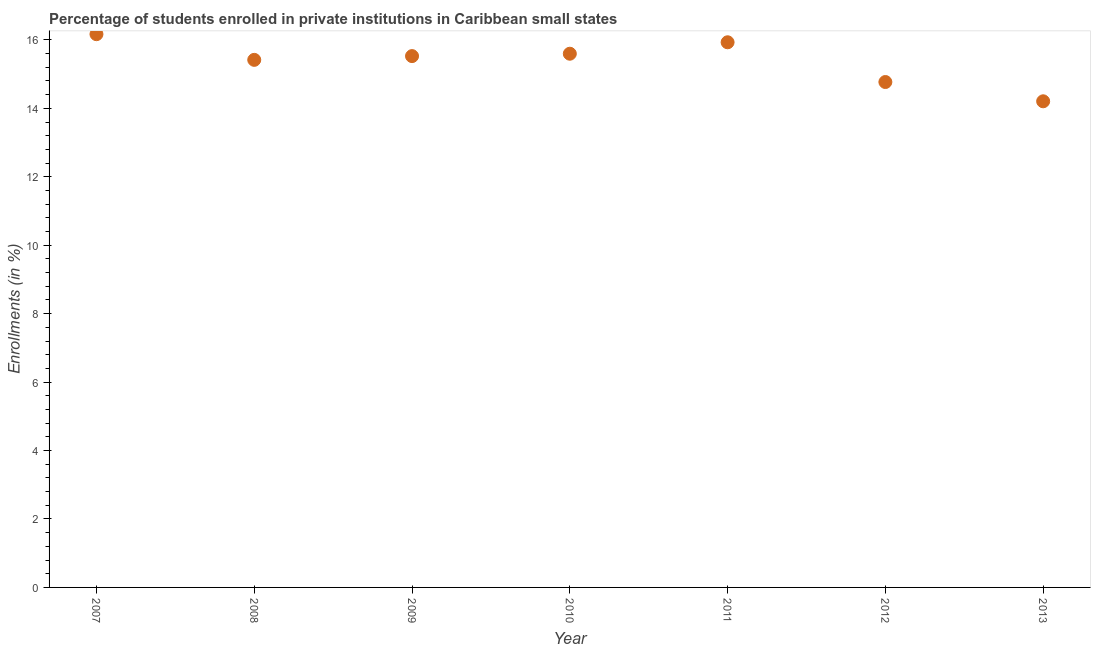What is the enrollments in private institutions in 2012?
Offer a terse response. 14.77. Across all years, what is the maximum enrollments in private institutions?
Your answer should be very brief. 16.17. Across all years, what is the minimum enrollments in private institutions?
Make the answer very short. 14.21. In which year was the enrollments in private institutions maximum?
Provide a succinct answer. 2007. What is the sum of the enrollments in private institutions?
Give a very brief answer. 107.62. What is the difference between the enrollments in private institutions in 2007 and 2008?
Provide a short and direct response. 0.75. What is the average enrollments in private institutions per year?
Your response must be concise. 15.37. What is the median enrollments in private institutions?
Offer a terse response. 15.53. Do a majority of the years between 2009 and 2010 (inclusive) have enrollments in private institutions greater than 8 %?
Offer a very short reply. Yes. What is the ratio of the enrollments in private institutions in 2008 to that in 2012?
Provide a short and direct response. 1.04. Is the enrollments in private institutions in 2008 less than that in 2010?
Keep it short and to the point. Yes. What is the difference between the highest and the second highest enrollments in private institutions?
Offer a very short reply. 0.24. What is the difference between the highest and the lowest enrollments in private institutions?
Your answer should be very brief. 1.96. In how many years, is the enrollments in private institutions greater than the average enrollments in private institutions taken over all years?
Your answer should be compact. 5. How many dotlines are there?
Offer a very short reply. 1. How many years are there in the graph?
Offer a very short reply. 7. Are the values on the major ticks of Y-axis written in scientific E-notation?
Make the answer very short. No. Does the graph contain any zero values?
Provide a succinct answer. No. Does the graph contain grids?
Your answer should be compact. No. What is the title of the graph?
Ensure brevity in your answer.  Percentage of students enrolled in private institutions in Caribbean small states. What is the label or title of the Y-axis?
Your response must be concise. Enrollments (in %). What is the Enrollments (in %) in 2007?
Your response must be concise. 16.17. What is the Enrollments (in %) in 2008?
Provide a succinct answer. 15.42. What is the Enrollments (in %) in 2009?
Provide a succinct answer. 15.53. What is the Enrollments (in %) in 2010?
Your response must be concise. 15.6. What is the Enrollments (in %) in 2011?
Offer a very short reply. 15.93. What is the Enrollments (in %) in 2012?
Your answer should be compact. 14.77. What is the Enrollments (in %) in 2013?
Your answer should be very brief. 14.21. What is the difference between the Enrollments (in %) in 2007 and 2008?
Make the answer very short. 0.75. What is the difference between the Enrollments (in %) in 2007 and 2009?
Offer a very short reply. 0.64. What is the difference between the Enrollments (in %) in 2007 and 2010?
Your answer should be very brief. 0.57. What is the difference between the Enrollments (in %) in 2007 and 2011?
Provide a short and direct response. 0.24. What is the difference between the Enrollments (in %) in 2007 and 2012?
Offer a very short reply. 1.4. What is the difference between the Enrollments (in %) in 2007 and 2013?
Your answer should be compact. 1.96. What is the difference between the Enrollments (in %) in 2008 and 2009?
Make the answer very short. -0.11. What is the difference between the Enrollments (in %) in 2008 and 2010?
Your response must be concise. -0.18. What is the difference between the Enrollments (in %) in 2008 and 2011?
Provide a short and direct response. -0.51. What is the difference between the Enrollments (in %) in 2008 and 2012?
Your answer should be very brief. 0.65. What is the difference between the Enrollments (in %) in 2008 and 2013?
Give a very brief answer. 1.21. What is the difference between the Enrollments (in %) in 2009 and 2010?
Keep it short and to the point. -0.07. What is the difference between the Enrollments (in %) in 2009 and 2011?
Make the answer very short. -0.4. What is the difference between the Enrollments (in %) in 2009 and 2012?
Your answer should be compact. 0.76. What is the difference between the Enrollments (in %) in 2009 and 2013?
Ensure brevity in your answer.  1.32. What is the difference between the Enrollments (in %) in 2010 and 2011?
Your answer should be very brief. -0.33. What is the difference between the Enrollments (in %) in 2010 and 2012?
Give a very brief answer. 0.83. What is the difference between the Enrollments (in %) in 2010 and 2013?
Give a very brief answer. 1.39. What is the difference between the Enrollments (in %) in 2011 and 2012?
Give a very brief answer. 1.16. What is the difference between the Enrollments (in %) in 2011 and 2013?
Give a very brief answer. 1.72. What is the difference between the Enrollments (in %) in 2012 and 2013?
Offer a very short reply. 0.56. What is the ratio of the Enrollments (in %) in 2007 to that in 2008?
Your response must be concise. 1.05. What is the ratio of the Enrollments (in %) in 2007 to that in 2009?
Your answer should be very brief. 1.04. What is the ratio of the Enrollments (in %) in 2007 to that in 2012?
Keep it short and to the point. 1.09. What is the ratio of the Enrollments (in %) in 2007 to that in 2013?
Your answer should be compact. 1.14. What is the ratio of the Enrollments (in %) in 2008 to that in 2009?
Provide a succinct answer. 0.99. What is the ratio of the Enrollments (in %) in 2008 to that in 2010?
Give a very brief answer. 0.99. What is the ratio of the Enrollments (in %) in 2008 to that in 2012?
Provide a succinct answer. 1.04. What is the ratio of the Enrollments (in %) in 2008 to that in 2013?
Give a very brief answer. 1.08. What is the ratio of the Enrollments (in %) in 2009 to that in 2012?
Give a very brief answer. 1.05. What is the ratio of the Enrollments (in %) in 2009 to that in 2013?
Your answer should be very brief. 1.09. What is the ratio of the Enrollments (in %) in 2010 to that in 2011?
Make the answer very short. 0.98. What is the ratio of the Enrollments (in %) in 2010 to that in 2012?
Your answer should be very brief. 1.06. What is the ratio of the Enrollments (in %) in 2010 to that in 2013?
Keep it short and to the point. 1.1. What is the ratio of the Enrollments (in %) in 2011 to that in 2012?
Your answer should be compact. 1.08. What is the ratio of the Enrollments (in %) in 2011 to that in 2013?
Provide a succinct answer. 1.12. 